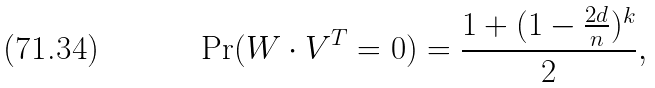<formula> <loc_0><loc_0><loc_500><loc_500>\Pr ( W \cdot V ^ { T } = 0 ) = \frac { 1 + ( 1 - \frac { 2 d } { n } ) ^ { k } } { 2 } ,</formula> 